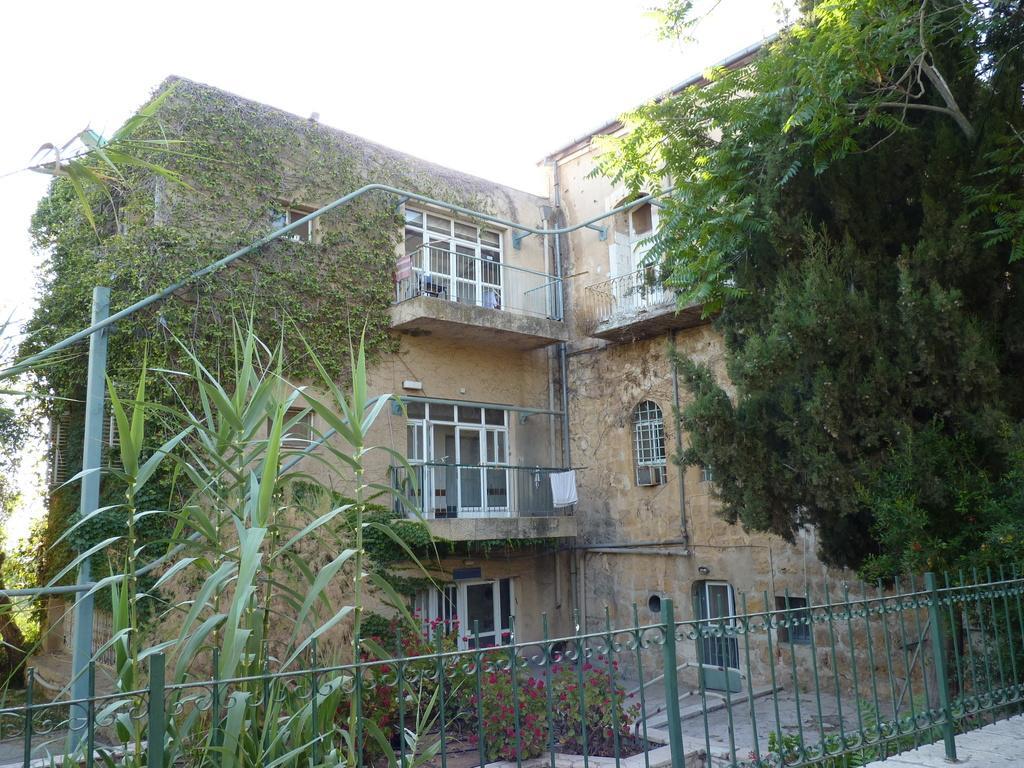In one or two sentences, can you explain what this image depicts? In this image we can see a building with creeper plants and there are few trees, plants with flowers and an iron railing in front of the building. 